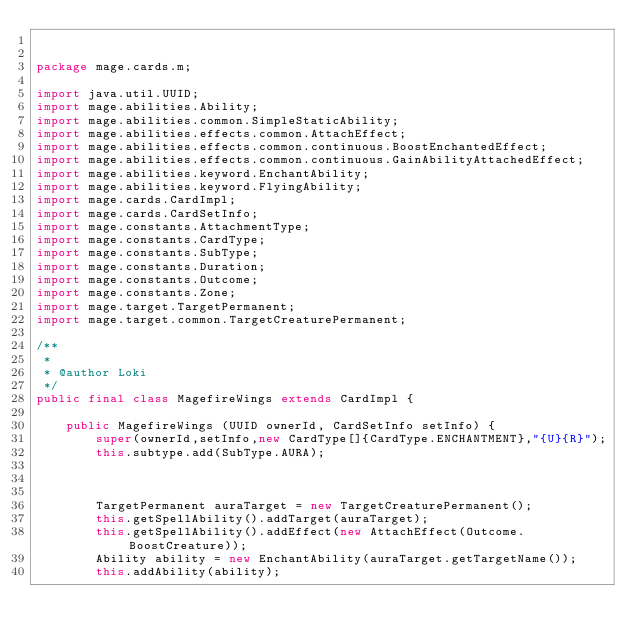Convert code to text. <code><loc_0><loc_0><loc_500><loc_500><_Java_>

package mage.cards.m;

import java.util.UUID;
import mage.abilities.Ability;
import mage.abilities.common.SimpleStaticAbility;
import mage.abilities.effects.common.AttachEffect;
import mage.abilities.effects.common.continuous.BoostEnchantedEffect;
import mage.abilities.effects.common.continuous.GainAbilityAttachedEffect;
import mage.abilities.keyword.EnchantAbility;
import mage.abilities.keyword.FlyingAbility;
import mage.cards.CardImpl;
import mage.cards.CardSetInfo;
import mage.constants.AttachmentType;
import mage.constants.CardType;
import mage.constants.SubType;
import mage.constants.Duration;
import mage.constants.Outcome;
import mage.constants.Zone;
import mage.target.TargetPermanent;
import mage.target.common.TargetCreaturePermanent;

/**
 *
 * @author Loki
 */
public final class MagefireWings extends CardImpl {

    public MagefireWings (UUID ownerId, CardSetInfo setInfo) {
        super(ownerId,setInfo,new CardType[]{CardType.ENCHANTMENT},"{U}{R}");
        this.subtype.add(SubType.AURA);



        TargetPermanent auraTarget = new TargetCreaturePermanent();
        this.getSpellAbility().addTarget(auraTarget);
        this.getSpellAbility().addEffect(new AttachEffect(Outcome.BoostCreature));
        Ability ability = new EnchantAbility(auraTarget.getTargetName());
        this.addAbility(ability);
</code> 